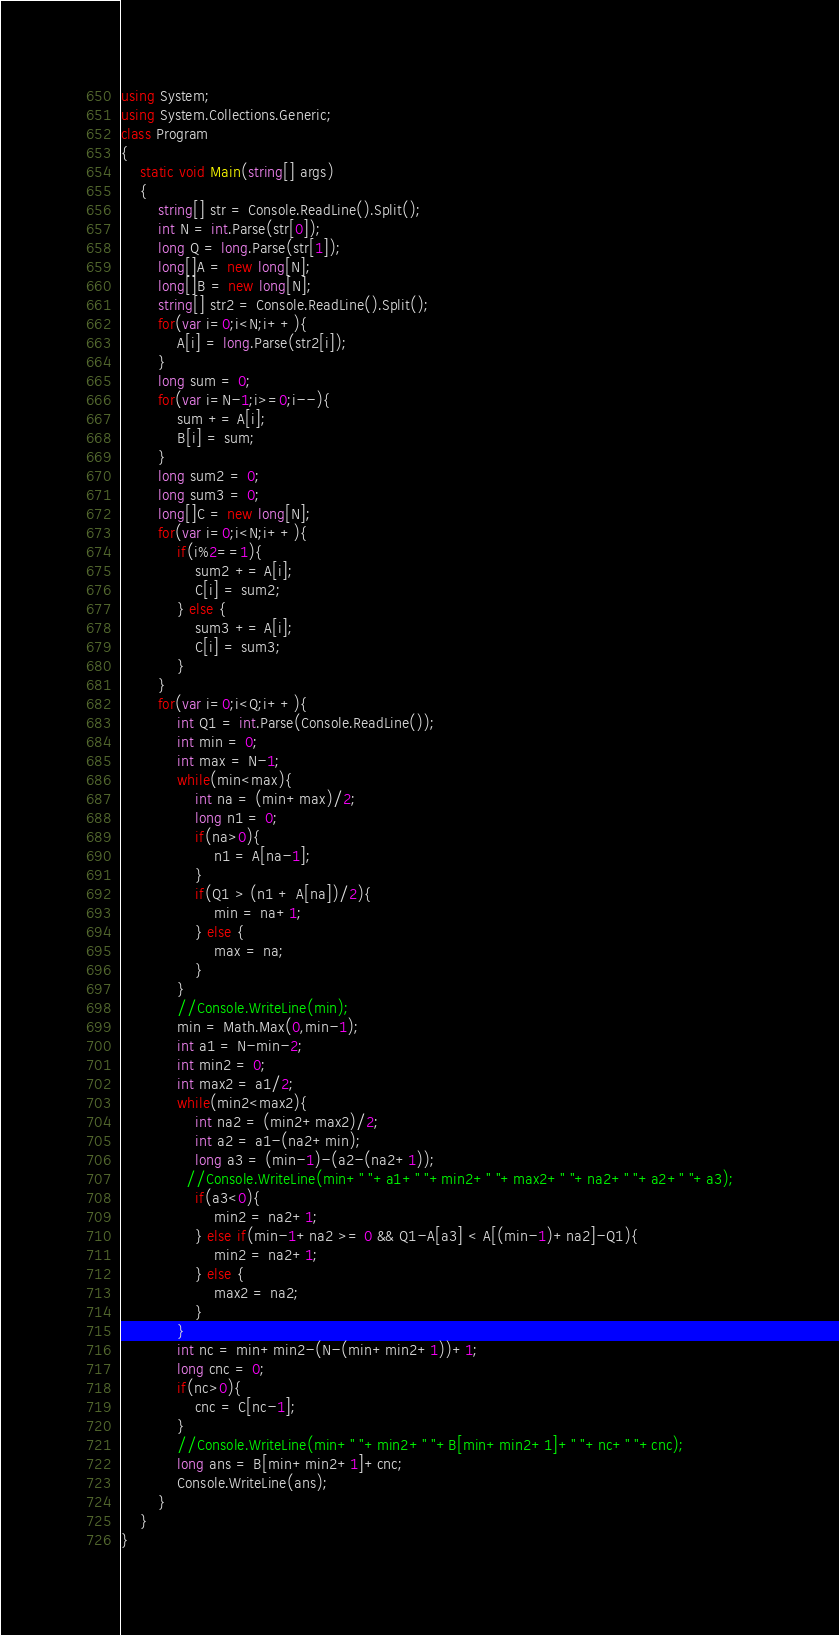Convert code to text. <code><loc_0><loc_0><loc_500><loc_500><_C#_>using System;
using System.Collections.Generic;
class Program
{
	static void Main(string[] args)
	{
		string[] str = Console.ReadLine().Split();
		int N = int.Parse(str[0]);
		long Q = long.Parse(str[1]);
		long[]A = new long[N];
		long[]B = new long[N];
		string[] str2 = Console.ReadLine().Split();
		for(var i=0;i<N;i++){
			A[i] = long.Parse(str2[i]);
		}
		long sum = 0;
		for(var i=N-1;i>=0;i--){
			sum += A[i];
			B[i] = sum;
		}
		long sum2 = 0;
		long sum3 = 0;
		long[]C = new long[N];
		for(var i=0;i<N;i++){
			if(i%2==1){
				sum2 += A[i];
				C[i] = sum2;
			} else {
				sum3 += A[i];
				C[i] = sum3;
			}
		}
		for(var i=0;i<Q;i++){
			int Q1 = int.Parse(Console.ReadLine());
			int min = 0;
			int max = N-1;
			while(min<max){
				int na = (min+max)/2;
				long n1 = 0;
				if(na>0){
					n1 = A[na-1];
				}
				if(Q1 > (n1 + A[na])/2){
					min = na+1;
				} else {
					max = na;
				}
			}
			//Console.WriteLine(min);
          	min = Math.Max(0,min-1);
			int a1 = N-min-2;
			int min2 = 0;
			int max2 = a1/2;
			while(min2<max2){	
				int na2 = (min2+max2)/2;
				int a2 = a1-(na2+min);
				long a3 = (min-1)-(a2-(na2+1));
              //Console.WriteLine(min+" "+a1+" "+min2+" "+max2+" "+na2+" "+a2+" "+a3);	
				if(a3<0){
					min2 = na2+1;
				} else if(min-1+na2 >= 0 && Q1-A[a3] < A[(min-1)+na2]-Q1){
					min2 = na2+1;
				} else {
					max2 = na2;
				}
			}
			int nc = min+min2-(N-(min+min2+1))+1;
			long cnc = 0;
			if(nc>0){
				cnc = C[nc-1];
			}
			//Console.WriteLine(min+" "+min2+" "+B[min+min2+1]+" "+nc+" "+cnc);
			long ans = B[min+min2+1]+cnc;
			Console.WriteLine(ans);
		}
	}
}</code> 